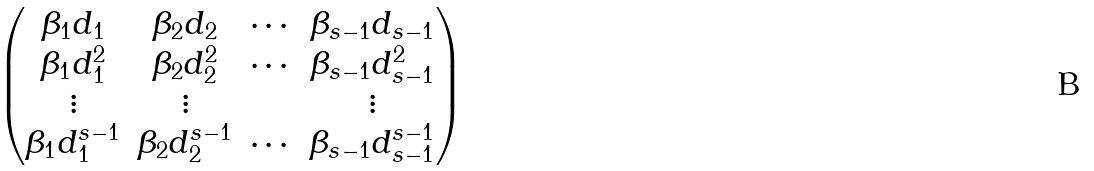<formula> <loc_0><loc_0><loc_500><loc_500>\begin{pmatrix} \beta _ { 1 } d _ { 1 } & \beta _ { 2 } d _ { 2 } & \cdots & \beta _ { s - 1 } d _ { s - 1 } \\ \beta _ { 1 } d _ { 1 } ^ { 2 } & \beta _ { 2 } d _ { 2 } ^ { 2 } & \cdots & \beta _ { s - 1 } d _ { s - 1 } ^ { 2 } \\ \vdots & \vdots & & \vdots \\ \beta _ { 1 } d _ { 1 } ^ { s - 1 } & \beta _ { 2 } d _ { 2 } ^ { s - 1 } & \cdots & \beta _ { s - 1 } d _ { s - 1 } ^ { s - 1 } \end{pmatrix}</formula> 